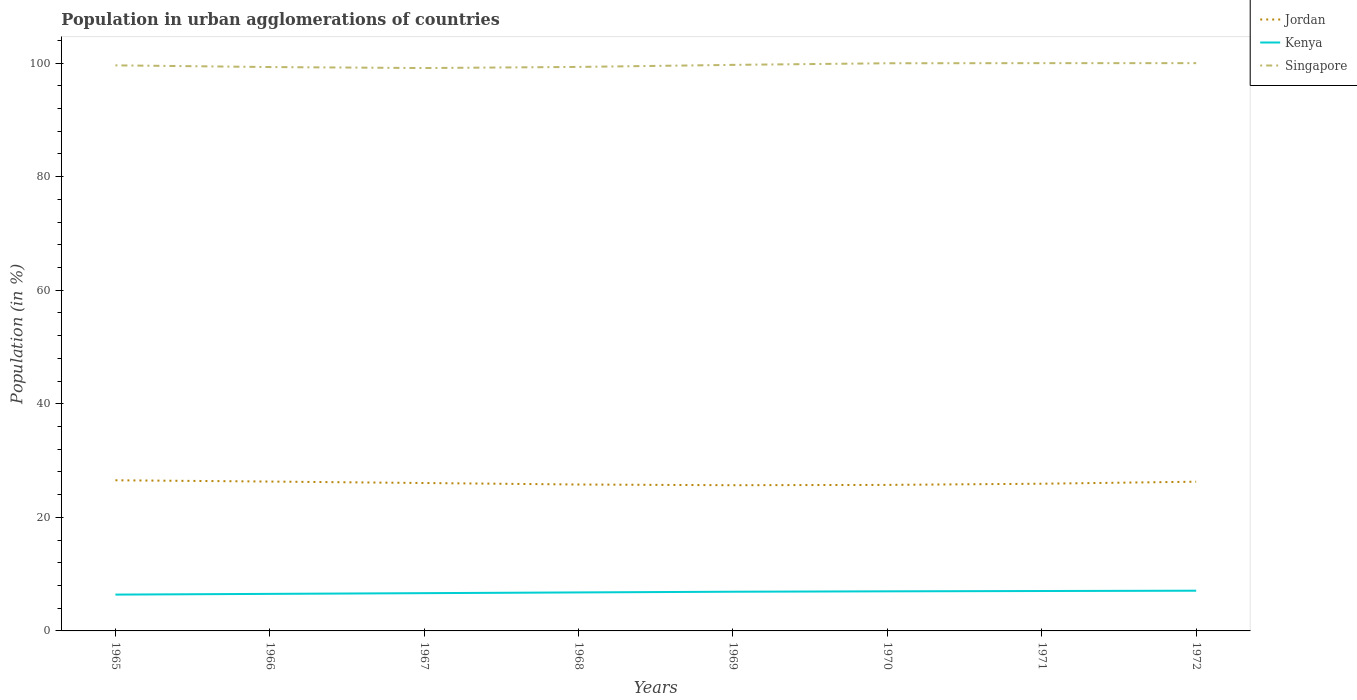Across all years, what is the maximum percentage of population in urban agglomerations in Singapore?
Your answer should be very brief. 99.14. In which year was the percentage of population in urban agglomerations in Singapore maximum?
Give a very brief answer. 1967. What is the total percentage of population in urban agglomerations in Kenya in the graph?
Provide a succinct answer. -0.32. What is the difference between the highest and the second highest percentage of population in urban agglomerations in Singapore?
Offer a terse response. 0.86. Is the percentage of population in urban agglomerations in Kenya strictly greater than the percentage of population in urban agglomerations in Singapore over the years?
Your response must be concise. Yes. How many lines are there?
Provide a succinct answer. 3. How many years are there in the graph?
Ensure brevity in your answer.  8. What is the difference between two consecutive major ticks on the Y-axis?
Offer a terse response. 20. Are the values on the major ticks of Y-axis written in scientific E-notation?
Keep it short and to the point. No. How many legend labels are there?
Your answer should be very brief. 3. How are the legend labels stacked?
Offer a terse response. Vertical. What is the title of the graph?
Provide a short and direct response. Population in urban agglomerations of countries. Does "Marshall Islands" appear as one of the legend labels in the graph?
Provide a succinct answer. No. What is the Population (in %) in Jordan in 1965?
Your answer should be compact. 26.53. What is the Population (in %) in Kenya in 1965?
Give a very brief answer. 6.4. What is the Population (in %) of Singapore in 1965?
Provide a short and direct response. 99.61. What is the Population (in %) of Jordan in 1966?
Make the answer very short. 26.31. What is the Population (in %) in Kenya in 1966?
Make the answer very short. 6.53. What is the Population (in %) of Singapore in 1966?
Make the answer very short. 99.31. What is the Population (in %) in Jordan in 1967?
Give a very brief answer. 26.05. What is the Population (in %) in Kenya in 1967?
Your response must be concise. 6.65. What is the Population (in %) of Singapore in 1967?
Provide a succinct answer. 99.14. What is the Population (in %) in Jordan in 1968?
Your response must be concise. 25.79. What is the Population (in %) of Kenya in 1968?
Ensure brevity in your answer.  6.78. What is the Population (in %) in Singapore in 1968?
Offer a terse response. 99.34. What is the Population (in %) of Jordan in 1969?
Ensure brevity in your answer.  25.66. What is the Population (in %) of Kenya in 1969?
Provide a succinct answer. 6.9. What is the Population (in %) in Singapore in 1969?
Ensure brevity in your answer.  99.7. What is the Population (in %) in Jordan in 1970?
Provide a short and direct response. 25.72. What is the Population (in %) of Kenya in 1970?
Offer a very short reply. 6.97. What is the Population (in %) of Singapore in 1970?
Ensure brevity in your answer.  99.98. What is the Population (in %) of Jordan in 1971?
Keep it short and to the point. 25.93. What is the Population (in %) in Kenya in 1971?
Your answer should be very brief. 7.03. What is the Population (in %) of Singapore in 1971?
Make the answer very short. 100. What is the Population (in %) of Jordan in 1972?
Provide a succinct answer. 26.28. What is the Population (in %) of Kenya in 1972?
Offer a very short reply. 7.08. Across all years, what is the maximum Population (in %) in Jordan?
Keep it short and to the point. 26.53. Across all years, what is the maximum Population (in %) in Kenya?
Ensure brevity in your answer.  7.08. Across all years, what is the minimum Population (in %) of Jordan?
Offer a terse response. 25.66. Across all years, what is the minimum Population (in %) in Kenya?
Offer a very short reply. 6.4. Across all years, what is the minimum Population (in %) of Singapore?
Provide a short and direct response. 99.14. What is the total Population (in %) of Jordan in the graph?
Your answer should be compact. 208.27. What is the total Population (in %) of Kenya in the graph?
Offer a very short reply. 54.35. What is the total Population (in %) in Singapore in the graph?
Your response must be concise. 797.07. What is the difference between the Population (in %) in Jordan in 1965 and that in 1966?
Give a very brief answer. 0.22. What is the difference between the Population (in %) in Kenya in 1965 and that in 1966?
Provide a succinct answer. -0.13. What is the difference between the Population (in %) in Singapore in 1965 and that in 1966?
Offer a terse response. 0.3. What is the difference between the Population (in %) of Jordan in 1965 and that in 1967?
Make the answer very short. 0.48. What is the difference between the Population (in %) of Kenya in 1965 and that in 1967?
Your answer should be compact. -0.25. What is the difference between the Population (in %) in Singapore in 1965 and that in 1967?
Your answer should be very brief. 0.47. What is the difference between the Population (in %) of Jordan in 1965 and that in 1968?
Your answer should be compact. 0.75. What is the difference between the Population (in %) of Kenya in 1965 and that in 1968?
Give a very brief answer. -0.38. What is the difference between the Population (in %) of Singapore in 1965 and that in 1968?
Provide a short and direct response. 0.28. What is the difference between the Population (in %) of Jordan in 1965 and that in 1969?
Provide a short and direct response. 0.87. What is the difference between the Population (in %) in Kenya in 1965 and that in 1969?
Provide a succinct answer. -0.51. What is the difference between the Population (in %) of Singapore in 1965 and that in 1969?
Provide a short and direct response. -0.08. What is the difference between the Population (in %) of Jordan in 1965 and that in 1970?
Ensure brevity in your answer.  0.81. What is the difference between the Population (in %) of Kenya in 1965 and that in 1970?
Make the answer very short. -0.57. What is the difference between the Population (in %) of Singapore in 1965 and that in 1970?
Provide a succinct answer. -0.37. What is the difference between the Population (in %) in Jordan in 1965 and that in 1971?
Your response must be concise. 0.6. What is the difference between the Population (in %) of Kenya in 1965 and that in 1971?
Give a very brief answer. -0.63. What is the difference between the Population (in %) in Singapore in 1965 and that in 1971?
Give a very brief answer. -0.39. What is the difference between the Population (in %) of Jordan in 1965 and that in 1972?
Provide a short and direct response. 0.25. What is the difference between the Population (in %) in Kenya in 1965 and that in 1972?
Provide a succinct answer. -0.68. What is the difference between the Population (in %) of Singapore in 1965 and that in 1972?
Offer a very short reply. -0.39. What is the difference between the Population (in %) of Jordan in 1966 and that in 1967?
Offer a very short reply. 0.26. What is the difference between the Population (in %) of Kenya in 1966 and that in 1967?
Your response must be concise. -0.13. What is the difference between the Population (in %) in Singapore in 1966 and that in 1967?
Provide a short and direct response. 0.17. What is the difference between the Population (in %) in Jordan in 1966 and that in 1968?
Provide a succinct answer. 0.52. What is the difference between the Population (in %) of Kenya in 1966 and that in 1968?
Your answer should be very brief. -0.25. What is the difference between the Population (in %) of Singapore in 1966 and that in 1968?
Provide a short and direct response. -0.02. What is the difference between the Population (in %) of Jordan in 1966 and that in 1969?
Give a very brief answer. 0.65. What is the difference between the Population (in %) of Kenya in 1966 and that in 1969?
Give a very brief answer. -0.38. What is the difference between the Population (in %) in Singapore in 1966 and that in 1969?
Provide a succinct answer. -0.38. What is the difference between the Population (in %) in Jordan in 1966 and that in 1970?
Your answer should be compact. 0.59. What is the difference between the Population (in %) of Kenya in 1966 and that in 1970?
Keep it short and to the point. -0.45. What is the difference between the Population (in %) in Singapore in 1966 and that in 1970?
Offer a very short reply. -0.67. What is the difference between the Population (in %) in Jordan in 1966 and that in 1971?
Give a very brief answer. 0.38. What is the difference between the Population (in %) of Kenya in 1966 and that in 1971?
Provide a short and direct response. -0.5. What is the difference between the Population (in %) in Singapore in 1966 and that in 1971?
Provide a succinct answer. -0.69. What is the difference between the Population (in %) of Jordan in 1966 and that in 1972?
Keep it short and to the point. 0.03. What is the difference between the Population (in %) of Kenya in 1966 and that in 1972?
Your answer should be very brief. -0.56. What is the difference between the Population (in %) in Singapore in 1966 and that in 1972?
Your response must be concise. -0.69. What is the difference between the Population (in %) of Jordan in 1967 and that in 1968?
Give a very brief answer. 0.26. What is the difference between the Population (in %) of Kenya in 1967 and that in 1968?
Offer a very short reply. -0.13. What is the difference between the Population (in %) of Singapore in 1967 and that in 1968?
Make the answer very short. -0.2. What is the difference between the Population (in %) in Jordan in 1967 and that in 1969?
Offer a very short reply. 0.39. What is the difference between the Population (in %) in Kenya in 1967 and that in 1969?
Offer a terse response. -0.25. What is the difference between the Population (in %) in Singapore in 1967 and that in 1969?
Make the answer very short. -0.56. What is the difference between the Population (in %) in Jordan in 1967 and that in 1970?
Provide a succinct answer. 0.33. What is the difference between the Population (in %) in Kenya in 1967 and that in 1970?
Give a very brief answer. -0.32. What is the difference between the Population (in %) of Singapore in 1967 and that in 1970?
Ensure brevity in your answer.  -0.84. What is the difference between the Population (in %) of Jordan in 1967 and that in 1971?
Provide a short and direct response. 0.12. What is the difference between the Population (in %) of Kenya in 1967 and that in 1971?
Offer a very short reply. -0.38. What is the difference between the Population (in %) of Singapore in 1967 and that in 1971?
Offer a very short reply. -0.86. What is the difference between the Population (in %) of Jordan in 1967 and that in 1972?
Ensure brevity in your answer.  -0.23. What is the difference between the Population (in %) of Kenya in 1967 and that in 1972?
Your answer should be very brief. -0.43. What is the difference between the Population (in %) in Singapore in 1967 and that in 1972?
Make the answer very short. -0.86. What is the difference between the Population (in %) in Jordan in 1968 and that in 1969?
Keep it short and to the point. 0.12. What is the difference between the Population (in %) of Kenya in 1968 and that in 1969?
Offer a very short reply. -0.12. What is the difference between the Population (in %) in Singapore in 1968 and that in 1969?
Keep it short and to the point. -0.36. What is the difference between the Population (in %) of Jordan in 1968 and that in 1970?
Provide a succinct answer. 0.07. What is the difference between the Population (in %) of Kenya in 1968 and that in 1970?
Your response must be concise. -0.19. What is the difference between the Population (in %) in Singapore in 1968 and that in 1970?
Keep it short and to the point. -0.64. What is the difference between the Population (in %) in Jordan in 1968 and that in 1971?
Your response must be concise. -0.14. What is the difference between the Population (in %) of Kenya in 1968 and that in 1971?
Your response must be concise. -0.25. What is the difference between the Population (in %) of Singapore in 1968 and that in 1971?
Keep it short and to the point. -0.66. What is the difference between the Population (in %) of Jordan in 1968 and that in 1972?
Ensure brevity in your answer.  -0.5. What is the difference between the Population (in %) of Kenya in 1968 and that in 1972?
Your answer should be compact. -0.3. What is the difference between the Population (in %) of Singapore in 1968 and that in 1972?
Your answer should be compact. -0.66. What is the difference between the Population (in %) in Jordan in 1969 and that in 1970?
Make the answer very short. -0.06. What is the difference between the Population (in %) in Kenya in 1969 and that in 1970?
Your answer should be very brief. -0.07. What is the difference between the Population (in %) of Singapore in 1969 and that in 1970?
Offer a terse response. -0.28. What is the difference between the Population (in %) of Jordan in 1969 and that in 1971?
Give a very brief answer. -0.26. What is the difference between the Population (in %) of Kenya in 1969 and that in 1971?
Your answer should be very brief. -0.12. What is the difference between the Population (in %) in Singapore in 1969 and that in 1971?
Provide a short and direct response. -0.3. What is the difference between the Population (in %) of Jordan in 1969 and that in 1972?
Your answer should be very brief. -0.62. What is the difference between the Population (in %) of Kenya in 1969 and that in 1972?
Give a very brief answer. -0.18. What is the difference between the Population (in %) of Singapore in 1969 and that in 1972?
Provide a short and direct response. -0.3. What is the difference between the Population (in %) in Jordan in 1970 and that in 1971?
Ensure brevity in your answer.  -0.21. What is the difference between the Population (in %) in Kenya in 1970 and that in 1971?
Provide a short and direct response. -0.06. What is the difference between the Population (in %) in Singapore in 1970 and that in 1971?
Give a very brief answer. -0.02. What is the difference between the Population (in %) of Jordan in 1970 and that in 1972?
Your answer should be compact. -0.56. What is the difference between the Population (in %) of Kenya in 1970 and that in 1972?
Ensure brevity in your answer.  -0.11. What is the difference between the Population (in %) in Singapore in 1970 and that in 1972?
Give a very brief answer. -0.02. What is the difference between the Population (in %) in Jordan in 1971 and that in 1972?
Keep it short and to the point. -0.36. What is the difference between the Population (in %) of Kenya in 1971 and that in 1972?
Provide a short and direct response. -0.05. What is the difference between the Population (in %) in Singapore in 1971 and that in 1972?
Provide a short and direct response. -0. What is the difference between the Population (in %) of Jordan in 1965 and the Population (in %) of Kenya in 1966?
Your response must be concise. 20.01. What is the difference between the Population (in %) in Jordan in 1965 and the Population (in %) in Singapore in 1966?
Provide a short and direct response. -72.78. What is the difference between the Population (in %) of Kenya in 1965 and the Population (in %) of Singapore in 1966?
Make the answer very short. -92.91. What is the difference between the Population (in %) in Jordan in 1965 and the Population (in %) in Kenya in 1967?
Your answer should be very brief. 19.88. What is the difference between the Population (in %) of Jordan in 1965 and the Population (in %) of Singapore in 1967?
Provide a succinct answer. -72.61. What is the difference between the Population (in %) of Kenya in 1965 and the Population (in %) of Singapore in 1967?
Your response must be concise. -92.74. What is the difference between the Population (in %) of Jordan in 1965 and the Population (in %) of Kenya in 1968?
Your answer should be very brief. 19.75. What is the difference between the Population (in %) in Jordan in 1965 and the Population (in %) in Singapore in 1968?
Your response must be concise. -72.8. What is the difference between the Population (in %) of Kenya in 1965 and the Population (in %) of Singapore in 1968?
Provide a succinct answer. -92.94. What is the difference between the Population (in %) of Jordan in 1965 and the Population (in %) of Kenya in 1969?
Make the answer very short. 19.63. What is the difference between the Population (in %) of Jordan in 1965 and the Population (in %) of Singapore in 1969?
Make the answer very short. -73.16. What is the difference between the Population (in %) of Kenya in 1965 and the Population (in %) of Singapore in 1969?
Your answer should be very brief. -93.3. What is the difference between the Population (in %) in Jordan in 1965 and the Population (in %) in Kenya in 1970?
Ensure brevity in your answer.  19.56. What is the difference between the Population (in %) in Jordan in 1965 and the Population (in %) in Singapore in 1970?
Give a very brief answer. -73.45. What is the difference between the Population (in %) in Kenya in 1965 and the Population (in %) in Singapore in 1970?
Offer a terse response. -93.58. What is the difference between the Population (in %) in Jordan in 1965 and the Population (in %) in Kenya in 1971?
Offer a very short reply. 19.5. What is the difference between the Population (in %) of Jordan in 1965 and the Population (in %) of Singapore in 1971?
Give a very brief answer. -73.47. What is the difference between the Population (in %) of Kenya in 1965 and the Population (in %) of Singapore in 1971?
Your response must be concise. -93.6. What is the difference between the Population (in %) in Jordan in 1965 and the Population (in %) in Kenya in 1972?
Provide a short and direct response. 19.45. What is the difference between the Population (in %) in Jordan in 1965 and the Population (in %) in Singapore in 1972?
Your answer should be very brief. -73.47. What is the difference between the Population (in %) in Kenya in 1965 and the Population (in %) in Singapore in 1972?
Give a very brief answer. -93.6. What is the difference between the Population (in %) of Jordan in 1966 and the Population (in %) of Kenya in 1967?
Your answer should be very brief. 19.66. What is the difference between the Population (in %) of Jordan in 1966 and the Population (in %) of Singapore in 1967?
Keep it short and to the point. -72.83. What is the difference between the Population (in %) in Kenya in 1966 and the Population (in %) in Singapore in 1967?
Provide a succinct answer. -92.61. What is the difference between the Population (in %) of Jordan in 1966 and the Population (in %) of Kenya in 1968?
Offer a terse response. 19.53. What is the difference between the Population (in %) in Jordan in 1966 and the Population (in %) in Singapore in 1968?
Your response must be concise. -73.03. What is the difference between the Population (in %) in Kenya in 1966 and the Population (in %) in Singapore in 1968?
Your answer should be very brief. -92.81. What is the difference between the Population (in %) in Jordan in 1966 and the Population (in %) in Kenya in 1969?
Your answer should be compact. 19.4. What is the difference between the Population (in %) of Jordan in 1966 and the Population (in %) of Singapore in 1969?
Give a very brief answer. -73.39. What is the difference between the Population (in %) in Kenya in 1966 and the Population (in %) in Singapore in 1969?
Ensure brevity in your answer.  -93.17. What is the difference between the Population (in %) of Jordan in 1966 and the Population (in %) of Kenya in 1970?
Offer a terse response. 19.34. What is the difference between the Population (in %) in Jordan in 1966 and the Population (in %) in Singapore in 1970?
Provide a short and direct response. -73.67. What is the difference between the Population (in %) in Kenya in 1966 and the Population (in %) in Singapore in 1970?
Offer a very short reply. -93.45. What is the difference between the Population (in %) of Jordan in 1966 and the Population (in %) of Kenya in 1971?
Your response must be concise. 19.28. What is the difference between the Population (in %) of Jordan in 1966 and the Population (in %) of Singapore in 1971?
Ensure brevity in your answer.  -73.69. What is the difference between the Population (in %) in Kenya in 1966 and the Population (in %) in Singapore in 1971?
Your answer should be very brief. -93.47. What is the difference between the Population (in %) in Jordan in 1966 and the Population (in %) in Kenya in 1972?
Offer a very short reply. 19.23. What is the difference between the Population (in %) of Jordan in 1966 and the Population (in %) of Singapore in 1972?
Keep it short and to the point. -73.69. What is the difference between the Population (in %) of Kenya in 1966 and the Population (in %) of Singapore in 1972?
Your response must be concise. -93.47. What is the difference between the Population (in %) in Jordan in 1967 and the Population (in %) in Kenya in 1968?
Your answer should be very brief. 19.27. What is the difference between the Population (in %) of Jordan in 1967 and the Population (in %) of Singapore in 1968?
Keep it short and to the point. -73.29. What is the difference between the Population (in %) in Kenya in 1967 and the Population (in %) in Singapore in 1968?
Provide a succinct answer. -92.68. What is the difference between the Population (in %) in Jordan in 1967 and the Population (in %) in Kenya in 1969?
Keep it short and to the point. 19.15. What is the difference between the Population (in %) of Jordan in 1967 and the Population (in %) of Singapore in 1969?
Offer a terse response. -73.64. What is the difference between the Population (in %) of Kenya in 1967 and the Population (in %) of Singapore in 1969?
Provide a short and direct response. -93.04. What is the difference between the Population (in %) in Jordan in 1967 and the Population (in %) in Kenya in 1970?
Provide a short and direct response. 19.08. What is the difference between the Population (in %) in Jordan in 1967 and the Population (in %) in Singapore in 1970?
Provide a short and direct response. -73.93. What is the difference between the Population (in %) of Kenya in 1967 and the Population (in %) of Singapore in 1970?
Your answer should be very brief. -93.33. What is the difference between the Population (in %) of Jordan in 1967 and the Population (in %) of Kenya in 1971?
Make the answer very short. 19.02. What is the difference between the Population (in %) in Jordan in 1967 and the Population (in %) in Singapore in 1971?
Your response must be concise. -73.95. What is the difference between the Population (in %) in Kenya in 1967 and the Population (in %) in Singapore in 1971?
Give a very brief answer. -93.35. What is the difference between the Population (in %) of Jordan in 1967 and the Population (in %) of Kenya in 1972?
Keep it short and to the point. 18.97. What is the difference between the Population (in %) of Jordan in 1967 and the Population (in %) of Singapore in 1972?
Make the answer very short. -73.95. What is the difference between the Population (in %) in Kenya in 1967 and the Population (in %) in Singapore in 1972?
Offer a terse response. -93.35. What is the difference between the Population (in %) of Jordan in 1968 and the Population (in %) of Kenya in 1969?
Your answer should be very brief. 18.88. What is the difference between the Population (in %) in Jordan in 1968 and the Population (in %) in Singapore in 1969?
Your answer should be compact. -73.91. What is the difference between the Population (in %) in Kenya in 1968 and the Population (in %) in Singapore in 1969?
Your response must be concise. -92.92. What is the difference between the Population (in %) of Jordan in 1968 and the Population (in %) of Kenya in 1970?
Offer a very short reply. 18.81. What is the difference between the Population (in %) in Jordan in 1968 and the Population (in %) in Singapore in 1970?
Ensure brevity in your answer.  -74.19. What is the difference between the Population (in %) in Kenya in 1968 and the Population (in %) in Singapore in 1970?
Provide a succinct answer. -93.2. What is the difference between the Population (in %) of Jordan in 1968 and the Population (in %) of Kenya in 1971?
Give a very brief answer. 18.76. What is the difference between the Population (in %) in Jordan in 1968 and the Population (in %) in Singapore in 1971?
Keep it short and to the point. -74.21. What is the difference between the Population (in %) of Kenya in 1968 and the Population (in %) of Singapore in 1971?
Offer a very short reply. -93.22. What is the difference between the Population (in %) in Jordan in 1968 and the Population (in %) in Kenya in 1972?
Give a very brief answer. 18.7. What is the difference between the Population (in %) of Jordan in 1968 and the Population (in %) of Singapore in 1972?
Give a very brief answer. -74.21. What is the difference between the Population (in %) in Kenya in 1968 and the Population (in %) in Singapore in 1972?
Provide a short and direct response. -93.22. What is the difference between the Population (in %) of Jordan in 1969 and the Population (in %) of Kenya in 1970?
Provide a short and direct response. 18.69. What is the difference between the Population (in %) of Jordan in 1969 and the Population (in %) of Singapore in 1970?
Make the answer very short. -74.32. What is the difference between the Population (in %) in Kenya in 1969 and the Population (in %) in Singapore in 1970?
Provide a succinct answer. -93.07. What is the difference between the Population (in %) in Jordan in 1969 and the Population (in %) in Kenya in 1971?
Make the answer very short. 18.63. What is the difference between the Population (in %) of Jordan in 1969 and the Population (in %) of Singapore in 1971?
Your response must be concise. -74.34. What is the difference between the Population (in %) in Kenya in 1969 and the Population (in %) in Singapore in 1971?
Your answer should be very brief. -93.09. What is the difference between the Population (in %) in Jordan in 1969 and the Population (in %) in Kenya in 1972?
Your answer should be very brief. 18.58. What is the difference between the Population (in %) in Jordan in 1969 and the Population (in %) in Singapore in 1972?
Your response must be concise. -74.34. What is the difference between the Population (in %) of Kenya in 1969 and the Population (in %) of Singapore in 1972?
Your response must be concise. -93.1. What is the difference between the Population (in %) in Jordan in 1970 and the Population (in %) in Kenya in 1971?
Keep it short and to the point. 18.69. What is the difference between the Population (in %) of Jordan in 1970 and the Population (in %) of Singapore in 1971?
Keep it short and to the point. -74.28. What is the difference between the Population (in %) of Kenya in 1970 and the Population (in %) of Singapore in 1971?
Ensure brevity in your answer.  -93.03. What is the difference between the Population (in %) in Jordan in 1970 and the Population (in %) in Kenya in 1972?
Give a very brief answer. 18.64. What is the difference between the Population (in %) of Jordan in 1970 and the Population (in %) of Singapore in 1972?
Provide a succinct answer. -74.28. What is the difference between the Population (in %) of Kenya in 1970 and the Population (in %) of Singapore in 1972?
Your answer should be very brief. -93.03. What is the difference between the Population (in %) of Jordan in 1971 and the Population (in %) of Kenya in 1972?
Your answer should be very brief. 18.84. What is the difference between the Population (in %) in Jordan in 1971 and the Population (in %) in Singapore in 1972?
Provide a short and direct response. -74.07. What is the difference between the Population (in %) of Kenya in 1971 and the Population (in %) of Singapore in 1972?
Provide a short and direct response. -92.97. What is the average Population (in %) in Jordan per year?
Give a very brief answer. 26.03. What is the average Population (in %) in Kenya per year?
Give a very brief answer. 6.79. What is the average Population (in %) in Singapore per year?
Give a very brief answer. 99.63. In the year 1965, what is the difference between the Population (in %) of Jordan and Population (in %) of Kenya?
Offer a terse response. 20.13. In the year 1965, what is the difference between the Population (in %) of Jordan and Population (in %) of Singapore?
Your answer should be very brief. -73.08. In the year 1965, what is the difference between the Population (in %) in Kenya and Population (in %) in Singapore?
Your answer should be compact. -93.21. In the year 1966, what is the difference between the Population (in %) in Jordan and Population (in %) in Kenya?
Offer a very short reply. 19.78. In the year 1966, what is the difference between the Population (in %) in Jordan and Population (in %) in Singapore?
Offer a very short reply. -73. In the year 1966, what is the difference between the Population (in %) of Kenya and Population (in %) of Singapore?
Provide a short and direct response. -92.79. In the year 1967, what is the difference between the Population (in %) of Jordan and Population (in %) of Kenya?
Make the answer very short. 19.4. In the year 1967, what is the difference between the Population (in %) of Jordan and Population (in %) of Singapore?
Your answer should be very brief. -73.09. In the year 1967, what is the difference between the Population (in %) of Kenya and Population (in %) of Singapore?
Make the answer very short. -92.49. In the year 1968, what is the difference between the Population (in %) of Jordan and Population (in %) of Kenya?
Make the answer very short. 19.01. In the year 1968, what is the difference between the Population (in %) in Jordan and Population (in %) in Singapore?
Keep it short and to the point. -73.55. In the year 1968, what is the difference between the Population (in %) of Kenya and Population (in %) of Singapore?
Your answer should be compact. -92.56. In the year 1969, what is the difference between the Population (in %) in Jordan and Population (in %) in Kenya?
Provide a short and direct response. 18.76. In the year 1969, what is the difference between the Population (in %) in Jordan and Population (in %) in Singapore?
Provide a short and direct response. -74.03. In the year 1969, what is the difference between the Population (in %) in Kenya and Population (in %) in Singapore?
Offer a terse response. -92.79. In the year 1970, what is the difference between the Population (in %) in Jordan and Population (in %) in Kenya?
Provide a short and direct response. 18.75. In the year 1970, what is the difference between the Population (in %) in Jordan and Population (in %) in Singapore?
Provide a succinct answer. -74.26. In the year 1970, what is the difference between the Population (in %) of Kenya and Population (in %) of Singapore?
Give a very brief answer. -93.01. In the year 1971, what is the difference between the Population (in %) in Jordan and Population (in %) in Kenya?
Provide a succinct answer. 18.9. In the year 1971, what is the difference between the Population (in %) in Jordan and Population (in %) in Singapore?
Your response must be concise. -74.07. In the year 1971, what is the difference between the Population (in %) in Kenya and Population (in %) in Singapore?
Ensure brevity in your answer.  -92.97. In the year 1972, what is the difference between the Population (in %) in Jordan and Population (in %) in Kenya?
Your answer should be very brief. 19.2. In the year 1972, what is the difference between the Population (in %) of Jordan and Population (in %) of Singapore?
Your answer should be compact. -73.72. In the year 1972, what is the difference between the Population (in %) in Kenya and Population (in %) in Singapore?
Offer a very short reply. -92.92. What is the ratio of the Population (in %) of Jordan in 1965 to that in 1966?
Your answer should be very brief. 1.01. What is the ratio of the Population (in %) in Kenya in 1965 to that in 1966?
Give a very brief answer. 0.98. What is the ratio of the Population (in %) in Singapore in 1965 to that in 1966?
Ensure brevity in your answer.  1. What is the ratio of the Population (in %) of Jordan in 1965 to that in 1967?
Your answer should be very brief. 1.02. What is the ratio of the Population (in %) in Kenya in 1965 to that in 1967?
Keep it short and to the point. 0.96. What is the ratio of the Population (in %) of Jordan in 1965 to that in 1968?
Make the answer very short. 1.03. What is the ratio of the Population (in %) in Kenya in 1965 to that in 1968?
Make the answer very short. 0.94. What is the ratio of the Population (in %) in Singapore in 1965 to that in 1968?
Your answer should be compact. 1. What is the ratio of the Population (in %) of Jordan in 1965 to that in 1969?
Your answer should be compact. 1.03. What is the ratio of the Population (in %) of Kenya in 1965 to that in 1969?
Your response must be concise. 0.93. What is the ratio of the Population (in %) in Jordan in 1965 to that in 1970?
Ensure brevity in your answer.  1.03. What is the ratio of the Population (in %) of Kenya in 1965 to that in 1970?
Your answer should be very brief. 0.92. What is the ratio of the Population (in %) of Singapore in 1965 to that in 1970?
Provide a succinct answer. 1. What is the ratio of the Population (in %) of Jordan in 1965 to that in 1971?
Your answer should be compact. 1.02. What is the ratio of the Population (in %) in Kenya in 1965 to that in 1971?
Make the answer very short. 0.91. What is the ratio of the Population (in %) in Singapore in 1965 to that in 1971?
Ensure brevity in your answer.  1. What is the ratio of the Population (in %) in Jordan in 1965 to that in 1972?
Provide a succinct answer. 1.01. What is the ratio of the Population (in %) of Kenya in 1965 to that in 1972?
Your answer should be compact. 0.9. What is the ratio of the Population (in %) in Jordan in 1966 to that in 1967?
Offer a very short reply. 1.01. What is the ratio of the Population (in %) in Kenya in 1966 to that in 1967?
Offer a terse response. 0.98. What is the ratio of the Population (in %) of Singapore in 1966 to that in 1967?
Your response must be concise. 1. What is the ratio of the Population (in %) of Jordan in 1966 to that in 1968?
Offer a very short reply. 1.02. What is the ratio of the Population (in %) of Kenya in 1966 to that in 1968?
Offer a terse response. 0.96. What is the ratio of the Population (in %) in Jordan in 1966 to that in 1969?
Provide a short and direct response. 1.03. What is the ratio of the Population (in %) in Kenya in 1966 to that in 1969?
Ensure brevity in your answer.  0.95. What is the ratio of the Population (in %) of Singapore in 1966 to that in 1969?
Keep it short and to the point. 1. What is the ratio of the Population (in %) of Jordan in 1966 to that in 1970?
Give a very brief answer. 1.02. What is the ratio of the Population (in %) in Kenya in 1966 to that in 1970?
Provide a succinct answer. 0.94. What is the ratio of the Population (in %) of Singapore in 1966 to that in 1970?
Your answer should be very brief. 0.99. What is the ratio of the Population (in %) of Jordan in 1966 to that in 1971?
Offer a terse response. 1.01. What is the ratio of the Population (in %) of Kenya in 1966 to that in 1971?
Your answer should be very brief. 0.93. What is the ratio of the Population (in %) of Jordan in 1966 to that in 1972?
Keep it short and to the point. 1. What is the ratio of the Population (in %) of Kenya in 1966 to that in 1972?
Provide a short and direct response. 0.92. What is the ratio of the Population (in %) in Singapore in 1966 to that in 1972?
Provide a short and direct response. 0.99. What is the ratio of the Population (in %) in Jordan in 1967 to that in 1968?
Keep it short and to the point. 1.01. What is the ratio of the Population (in %) in Kenya in 1967 to that in 1968?
Offer a terse response. 0.98. What is the ratio of the Population (in %) of Jordan in 1967 to that in 1969?
Make the answer very short. 1.02. What is the ratio of the Population (in %) of Kenya in 1967 to that in 1969?
Offer a very short reply. 0.96. What is the ratio of the Population (in %) in Jordan in 1967 to that in 1970?
Offer a terse response. 1.01. What is the ratio of the Population (in %) in Kenya in 1967 to that in 1970?
Keep it short and to the point. 0.95. What is the ratio of the Population (in %) in Kenya in 1967 to that in 1971?
Keep it short and to the point. 0.95. What is the ratio of the Population (in %) in Kenya in 1967 to that in 1972?
Your answer should be compact. 0.94. What is the ratio of the Population (in %) of Kenya in 1968 to that in 1969?
Offer a terse response. 0.98. What is the ratio of the Population (in %) of Kenya in 1968 to that in 1970?
Keep it short and to the point. 0.97. What is the ratio of the Population (in %) of Singapore in 1968 to that in 1970?
Give a very brief answer. 0.99. What is the ratio of the Population (in %) of Kenya in 1968 to that in 1971?
Your answer should be very brief. 0.96. What is the ratio of the Population (in %) in Jordan in 1968 to that in 1972?
Keep it short and to the point. 0.98. What is the ratio of the Population (in %) in Kenya in 1968 to that in 1972?
Your response must be concise. 0.96. What is the ratio of the Population (in %) in Kenya in 1969 to that in 1970?
Make the answer very short. 0.99. What is the ratio of the Population (in %) of Jordan in 1969 to that in 1971?
Give a very brief answer. 0.99. What is the ratio of the Population (in %) of Kenya in 1969 to that in 1971?
Give a very brief answer. 0.98. What is the ratio of the Population (in %) of Jordan in 1969 to that in 1972?
Your answer should be very brief. 0.98. What is the ratio of the Population (in %) of Kenya in 1969 to that in 1972?
Your answer should be very brief. 0.97. What is the ratio of the Population (in %) of Singapore in 1969 to that in 1972?
Provide a succinct answer. 1. What is the ratio of the Population (in %) in Jordan in 1970 to that in 1971?
Make the answer very short. 0.99. What is the ratio of the Population (in %) in Kenya in 1970 to that in 1971?
Offer a very short reply. 0.99. What is the ratio of the Population (in %) of Jordan in 1970 to that in 1972?
Keep it short and to the point. 0.98. What is the ratio of the Population (in %) of Kenya in 1970 to that in 1972?
Keep it short and to the point. 0.98. What is the ratio of the Population (in %) in Jordan in 1971 to that in 1972?
Provide a short and direct response. 0.99. What is the ratio of the Population (in %) in Singapore in 1971 to that in 1972?
Keep it short and to the point. 1. What is the difference between the highest and the second highest Population (in %) of Jordan?
Your answer should be compact. 0.22. What is the difference between the highest and the second highest Population (in %) of Kenya?
Keep it short and to the point. 0.05. What is the difference between the highest and the second highest Population (in %) in Singapore?
Provide a succinct answer. 0. What is the difference between the highest and the lowest Population (in %) of Jordan?
Provide a short and direct response. 0.87. What is the difference between the highest and the lowest Population (in %) of Kenya?
Your answer should be very brief. 0.68. What is the difference between the highest and the lowest Population (in %) in Singapore?
Provide a succinct answer. 0.86. 